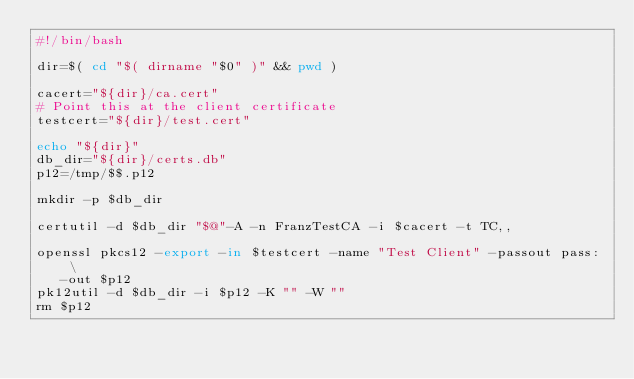<code> <loc_0><loc_0><loc_500><loc_500><_Bash_>#!/bin/bash

dir=$( cd "$( dirname "$0" )" && pwd )

cacert="${dir}/ca.cert"
# Point this at the client certificate
testcert="${dir}/test.cert"

echo "${dir}"
db_dir="${dir}/certs.db"
p12=/tmp/$$.p12

mkdir -p $db_dir

certutil -d $db_dir "$@"-A -n FranzTestCA -i $cacert -t TC,,

openssl pkcs12 -export -in $testcert -name "Test Client" -passout pass: \
   -out $p12
pk12util -d $db_dir -i $p12 -K "" -W ""
rm $p12
</code> 